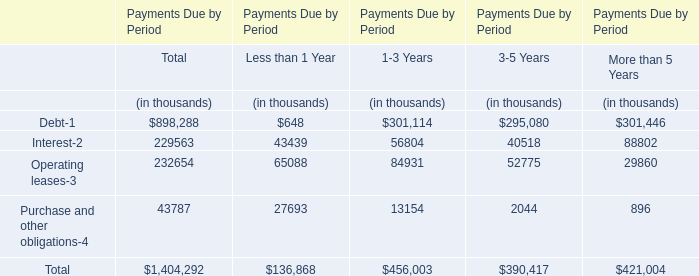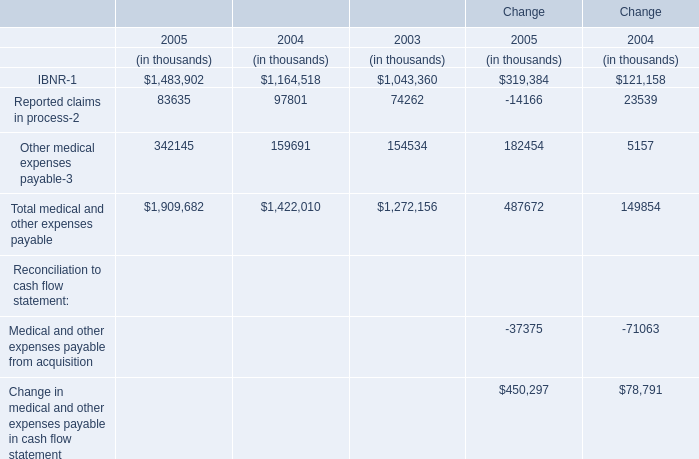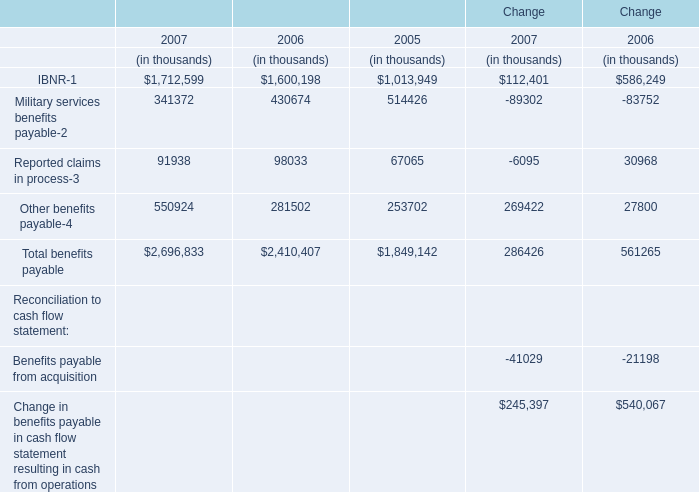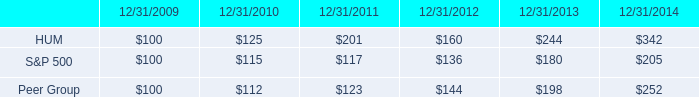what was the percent of the change in the stock price performance for hum from 2010 to 2011 
Computations: ((201 - 125) / 125)
Answer: 0.608. 